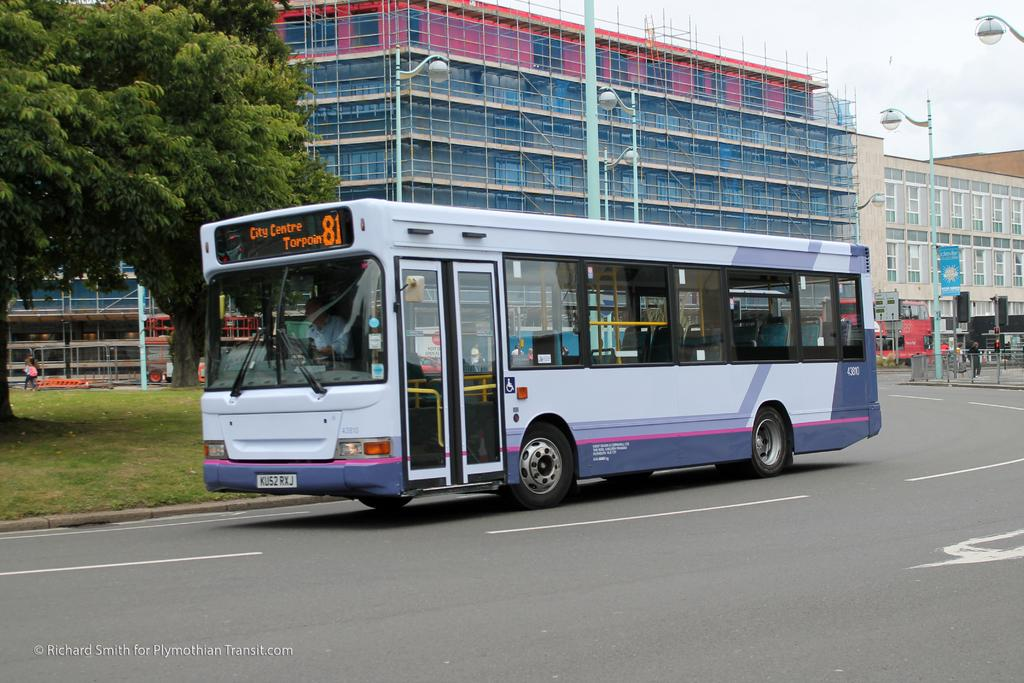Provide a one-sentence caption for the provided image. the number 81 bus going to city centre torpoin. 